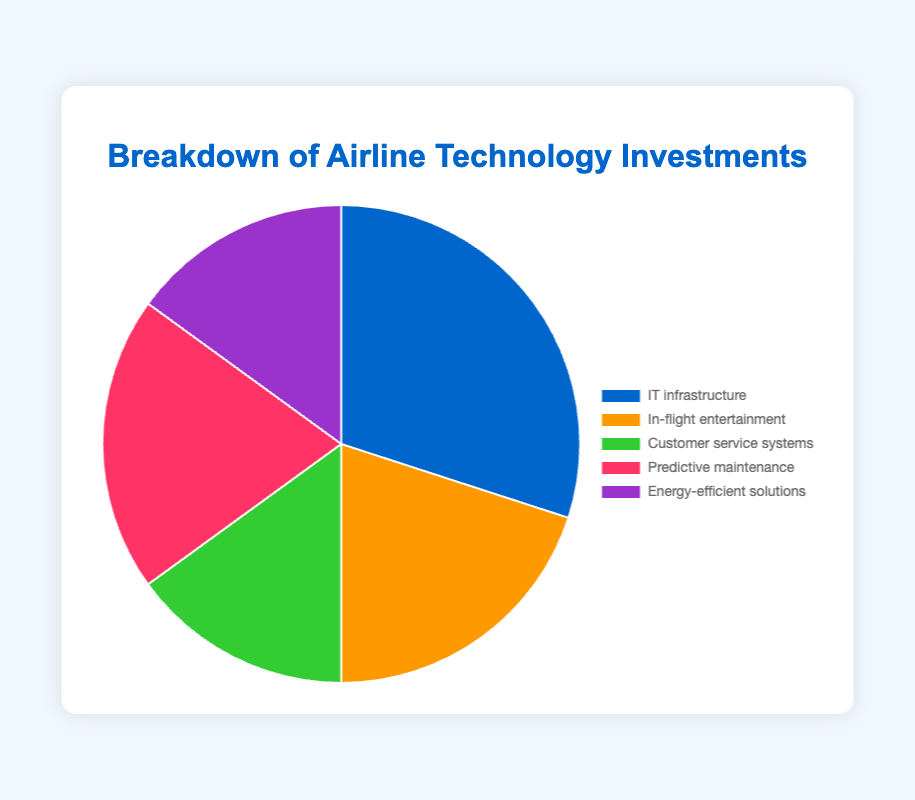What is the largest single category of investment? The segment of the pie chart representing "IT infrastructure" is the largest, taking up 30% of the total investments.
Answer: IT infrastructure How do the investments in "Predictive maintenance" and "In-flight entertainment" compare? Both "Predictive maintenance" and "In-flight entertainment" segments look similar, each occupying 20% of the pie chart.
Answer: Equal Which category has the smallest investment, and what percentage is it? The pie chart shows that both "Customer service systems" and "Energy-efficient solutions" have equally small segments, both at 15%.
Answer: Customer service systems and Energy-efficient solutions at 15% What is the sum of the investments in "Customer service systems" and "Energy-efficient solutions"? "Customer service systems" and "Energy-efficient solutions" each occupy 15% of the pie chart. Adding these gives 15% + 15% = 30%.
Answer: 30% Rank the categories from highest to lowest investment percentage. The largest segment is "IT infrastructure" (30%), followed by "In-flight entertainment" and "Predictive maintenance" (each 20%), and finally "Customer service systems" and "Energy-efficient solutions" (each 15%).
Answer: IT infrastructure, In-flight entertainment = Predictive maintenance, Customer service systems = Energy-efficient solutions Is the total investment in "Customer service systems" and "Energy-efficient solutions" greater than the investment in "Predictive maintenance"? "Customer service systems" and "Energy-efficient solutions" together total 30% (15% + 15%), which is greater than the 20% invested in "Predictive maintenance".
Answer: Yes Which categories together make up half of the total investments? "IT infrastructure" (30%) and "Customer service systems" (15%) make a combined 45%. Adding any 5% or more from another category would exceed half. The combination of "IT infrastructure" (30%) and "Predictive maintenance" (20%) makes exactly 50%.
Answer: IT infrastructure and Predictive maintenance How much more is invested in "IT infrastructure" compared to "Energy-efficient solutions"? The investment in "IT infrastructure" is 30%, while "Energy-efficient solutions" is 15%. 30% - 15% = 15%.
Answer: 15% If the investment in "In-flight entertainment" were doubled, what would its new percentage be, and how would it compare to the current largest investment category? Doubling "In-flight entertainment" (20%) would result in 40%. This would exceed the current largest "IT infrastructure" at 30%.
Answer: 40%; greater than "IT infrastructure" 